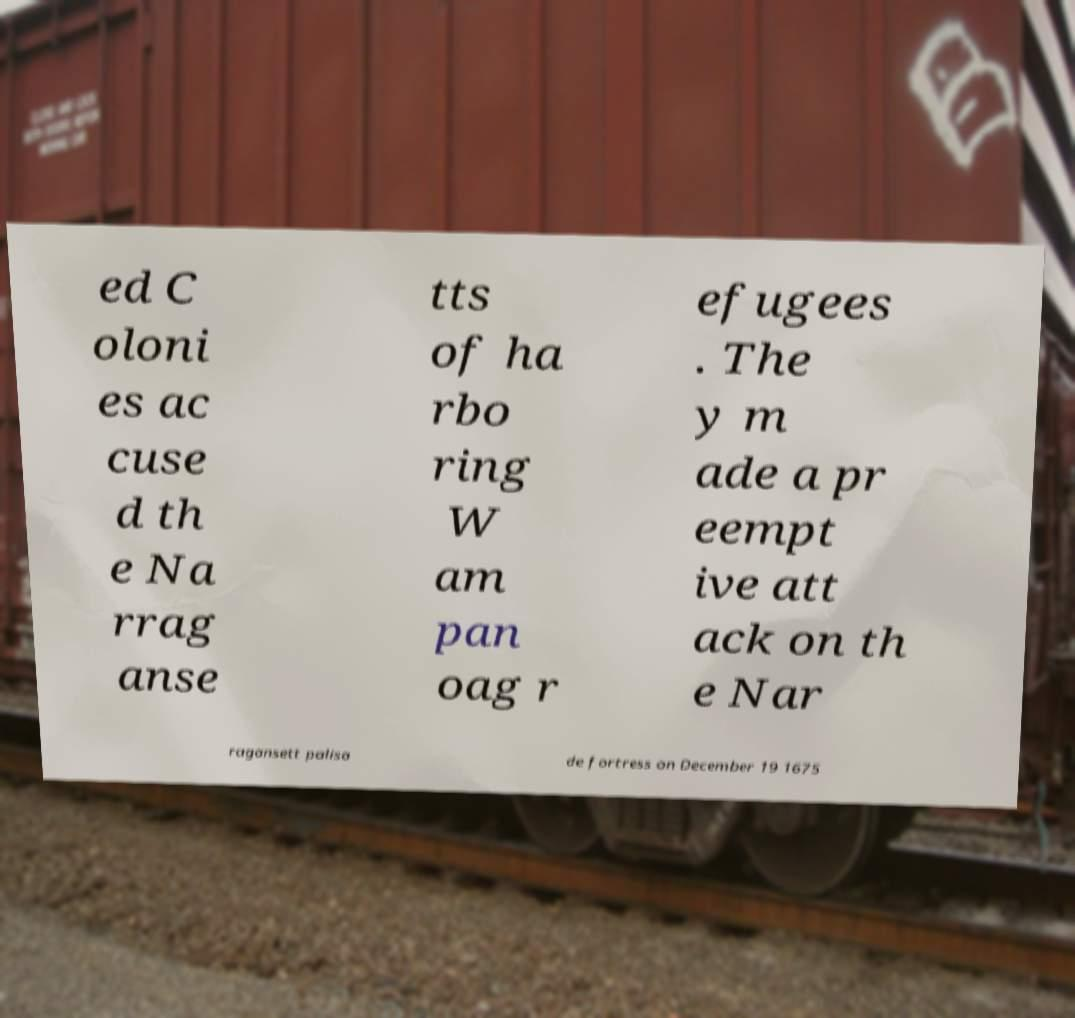Can you read and provide the text displayed in the image?This photo seems to have some interesting text. Can you extract and type it out for me? ed C oloni es ac cuse d th e Na rrag anse tts of ha rbo ring W am pan oag r efugees . The y m ade a pr eempt ive att ack on th e Nar ragansett palisa de fortress on December 19 1675 